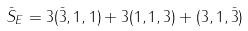Convert formula to latex. <formula><loc_0><loc_0><loc_500><loc_500>\bar { S } _ { E } = 3 ( \bar { 3 } , 1 , 1 ) + 3 ( 1 , 1 , 3 ) + ( 3 , 1 , \bar { 3 } )</formula> 